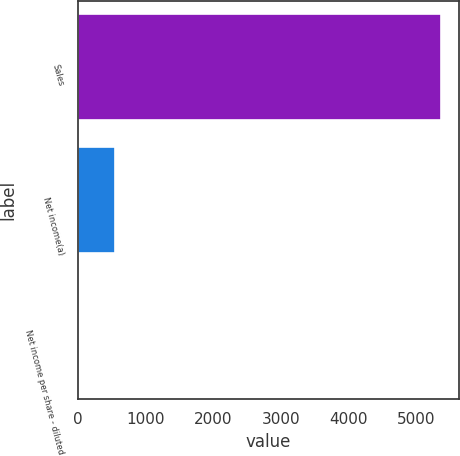Convert chart to OTSL. <chart><loc_0><loc_0><loc_500><loc_500><bar_chart><fcel>Sales<fcel>Net income(a)<fcel>Net income per share - diluted<nl><fcel>5355.9<fcel>537.68<fcel>2.32<nl></chart> 